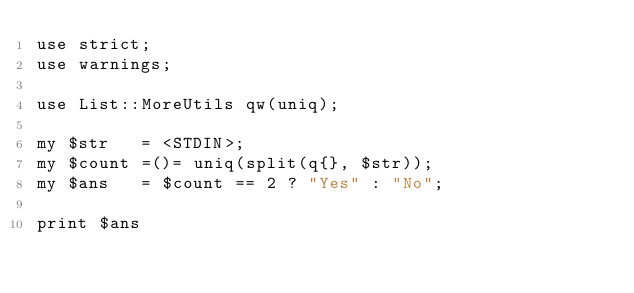Convert code to text. <code><loc_0><loc_0><loc_500><loc_500><_Perl_>use strict;
use warnings;

use List::MoreUtils qw(uniq);

my $str   = <STDIN>;
my $count =()= uniq(split(q{}, $str));
my $ans   = $count == 2 ? "Yes" : "No";

print $ans
</code> 